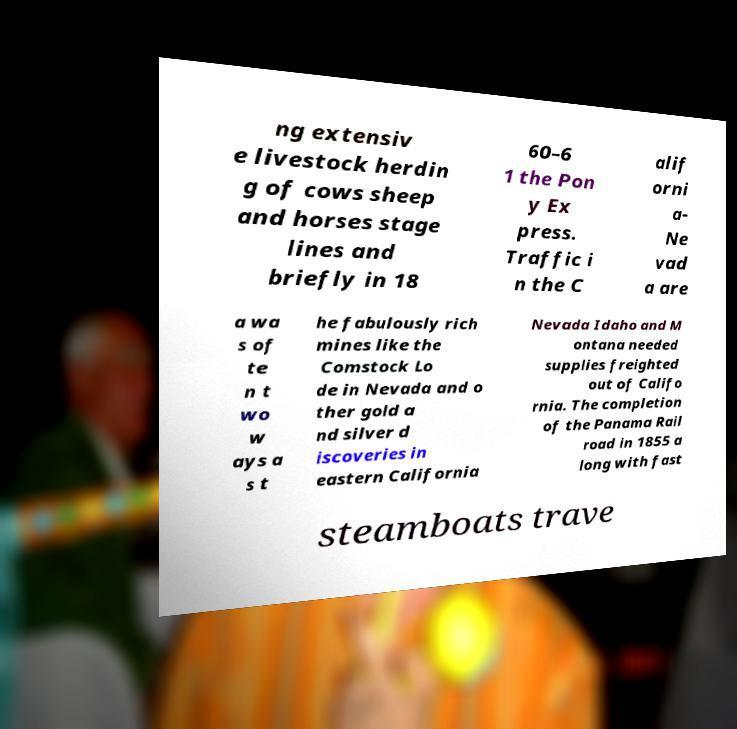Could you assist in decoding the text presented in this image and type it out clearly? ng extensiv e livestock herdin g of cows sheep and horses stage lines and briefly in 18 60–6 1 the Pon y Ex press. Traffic i n the C alif orni a- Ne vad a are a wa s of te n t wo w ays a s t he fabulously rich mines like the Comstock Lo de in Nevada and o ther gold a nd silver d iscoveries in eastern California Nevada Idaho and M ontana needed supplies freighted out of Califo rnia. The completion of the Panama Rail road in 1855 a long with fast steamboats trave 